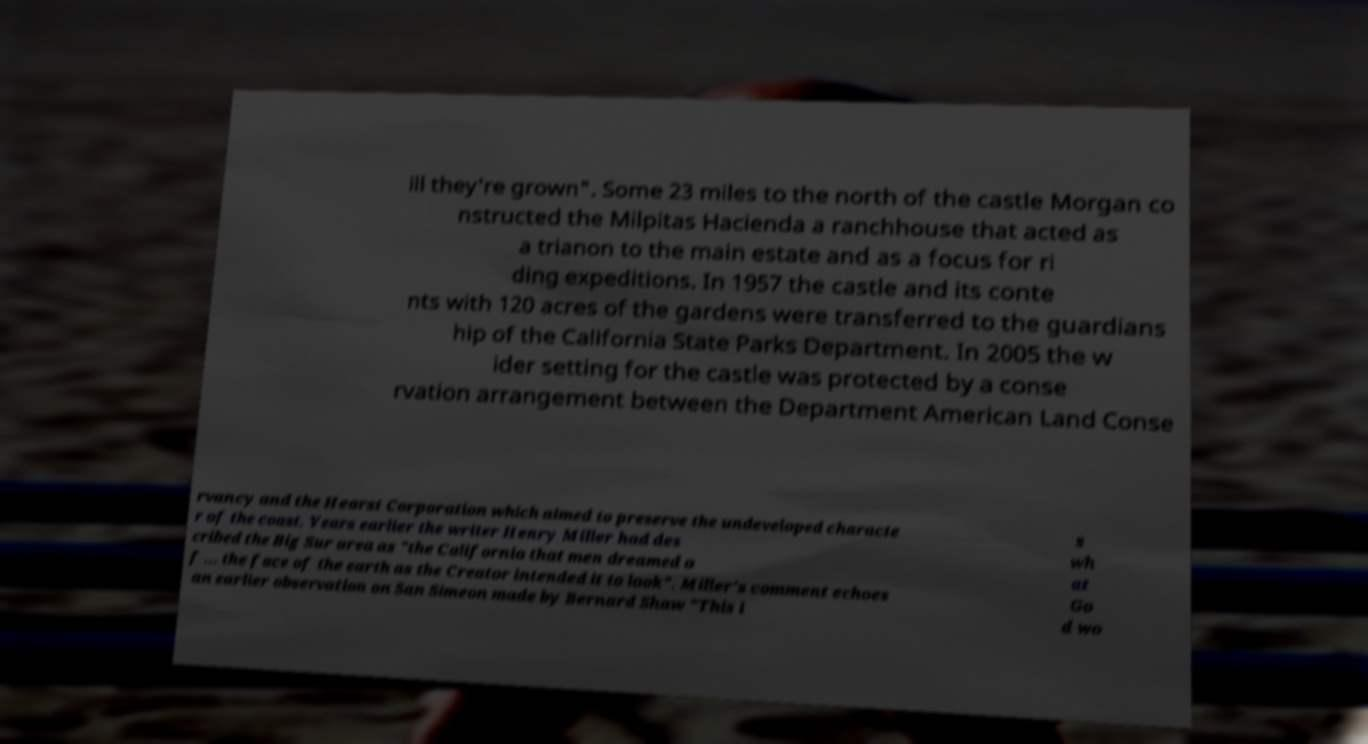I need the written content from this picture converted into text. Can you do that? ill they're grown". Some 23 miles to the north of the castle Morgan co nstructed the Milpitas Hacienda a ranchhouse that acted as a trianon to the main estate and as a focus for ri ding expeditions. In 1957 the castle and its conte nts with 120 acres of the gardens were transferred to the guardians hip of the California State Parks Department. In 2005 the w ider setting for the castle was protected by a conse rvation arrangement between the Department American Land Conse rvancy and the Hearst Corporation which aimed to preserve the undeveloped characte r of the coast. Years earlier the writer Henry Miller had des cribed the Big Sur area as "the California that men dreamed o f ... the face of the earth as the Creator intended it to look". Miller's comment echoes an earlier observation on San Simeon made by Bernard Shaw "This i s wh at Go d wo 